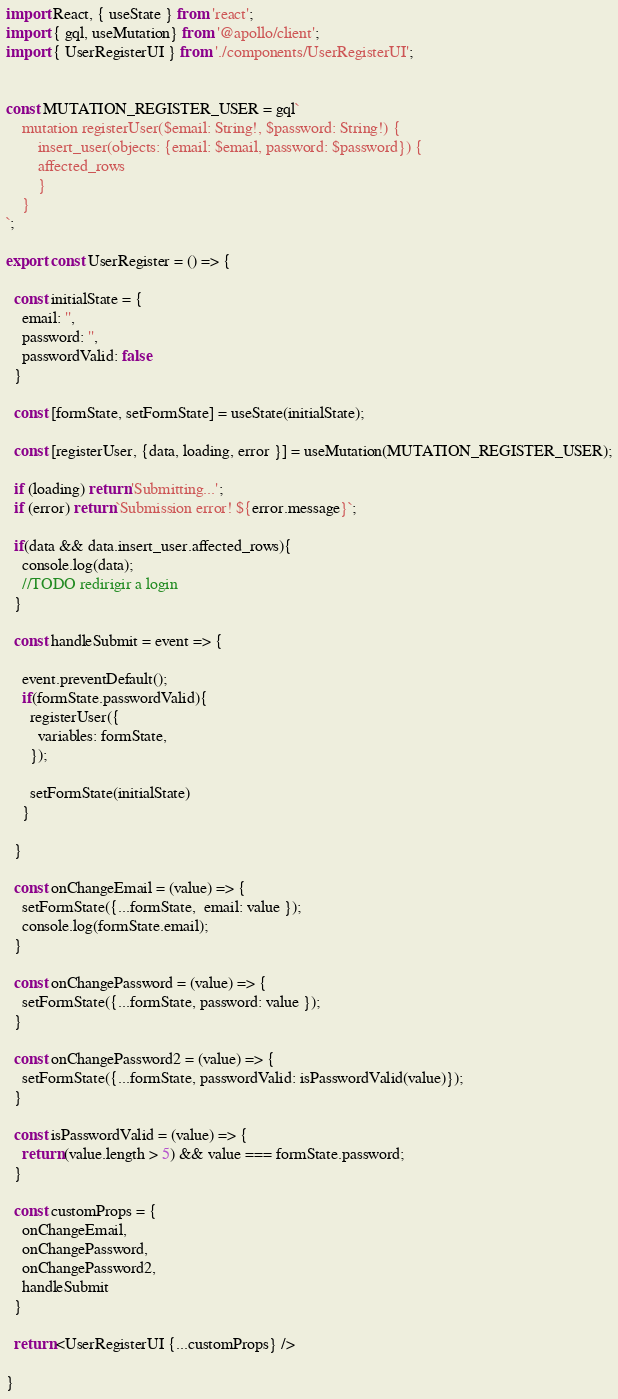Convert code to text. <code><loc_0><loc_0><loc_500><loc_500><_JavaScript_>import React, { useState } from 'react';
import { gql, useMutation} from '@apollo/client';
import { UserRegisterUI } from './components/UserRegisterUI';


const MUTATION_REGISTER_USER = gql`
    mutation registerUser($email: String!, $password: String!) {
        insert_user(objects: {email: $email, password: $password}) {
        affected_rows
        }
    }
`;

export const UserRegister = () => {

  const initialState = {
    email: '',
    password: '',
    passwordValid: false
  }

  const [formState, setFormState] = useState(initialState);

  const [registerUser, {data, loading, error }] = useMutation(MUTATION_REGISTER_USER);

  if (loading) return 'Submitting...';
  if (error) return `Submission error! ${error.message}`;

  if(data && data.insert_user.affected_rows){
    console.log(data);
    //TODO redirigir a login
  } 

  const handleSubmit = event => {

    event.preventDefault();
    if(formState.passwordValid){
      registerUser({
        variables: formState,
      });
  
      setFormState(initialState)
    }

  }

  const onChangeEmail = (value) => {
    setFormState({...formState,  email: value });
    console.log(formState.email);
  }

  const onChangePassword = (value) => {
    setFormState({...formState, password: value });
  }

  const onChangePassword2 = (value) => {
    setFormState({...formState, passwordValid: isPasswordValid(value)});
  }

  const isPasswordValid = (value) => {
    return (value.length > 5) && value === formState.password;
  }

  const customProps = {
    onChangeEmail,
    onChangePassword,
    onChangePassword2,
    handleSubmit
  }

  return <UserRegisterUI {...customProps} />

}</code> 